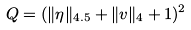Convert formula to latex. <formula><loc_0><loc_0><loc_500><loc_500>Q = ( \| \eta \| _ { 4 . 5 } + \| v \| _ { 4 } + 1 ) ^ { 2 }</formula> 